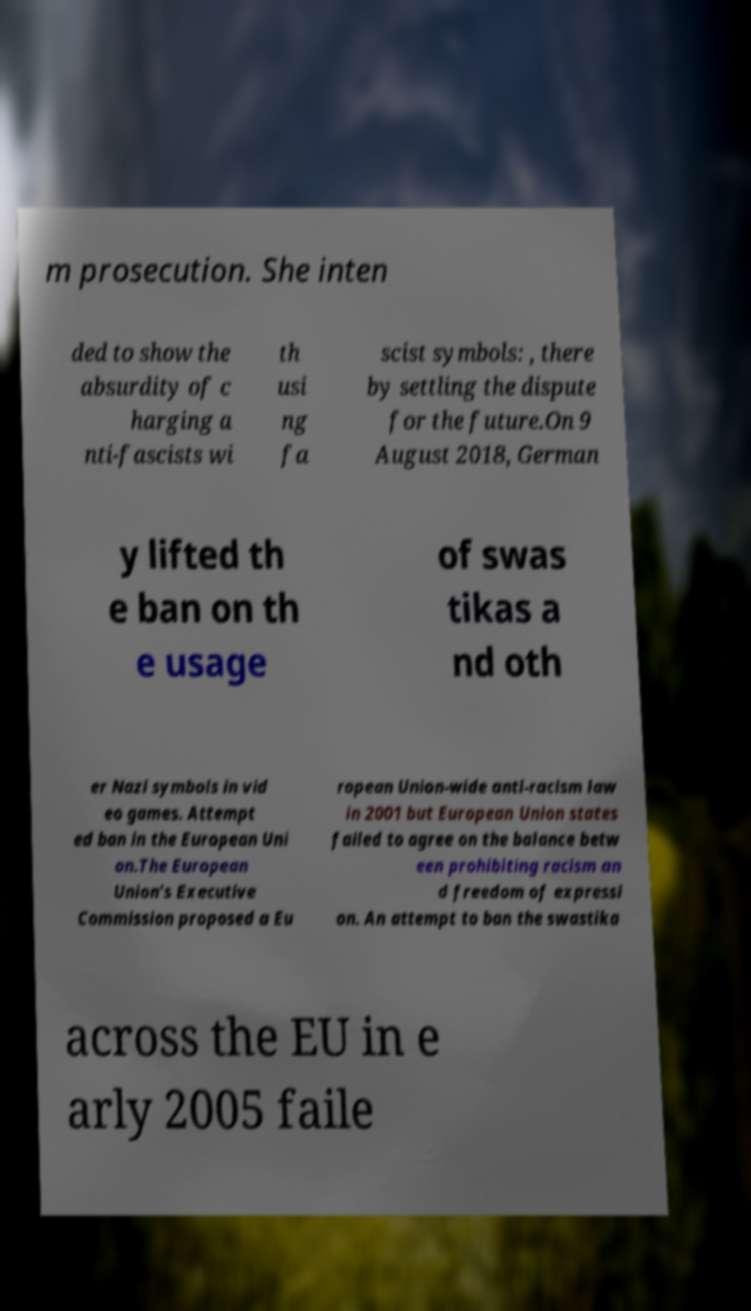I need the written content from this picture converted into text. Can you do that? m prosecution. She inten ded to show the absurdity of c harging a nti-fascists wi th usi ng fa scist symbols: , there by settling the dispute for the future.On 9 August 2018, German y lifted th e ban on th e usage of swas tikas a nd oth er Nazi symbols in vid eo games. Attempt ed ban in the European Uni on.The European Union's Executive Commission proposed a Eu ropean Union-wide anti-racism law in 2001 but European Union states failed to agree on the balance betw een prohibiting racism an d freedom of expressi on. An attempt to ban the swastika across the EU in e arly 2005 faile 